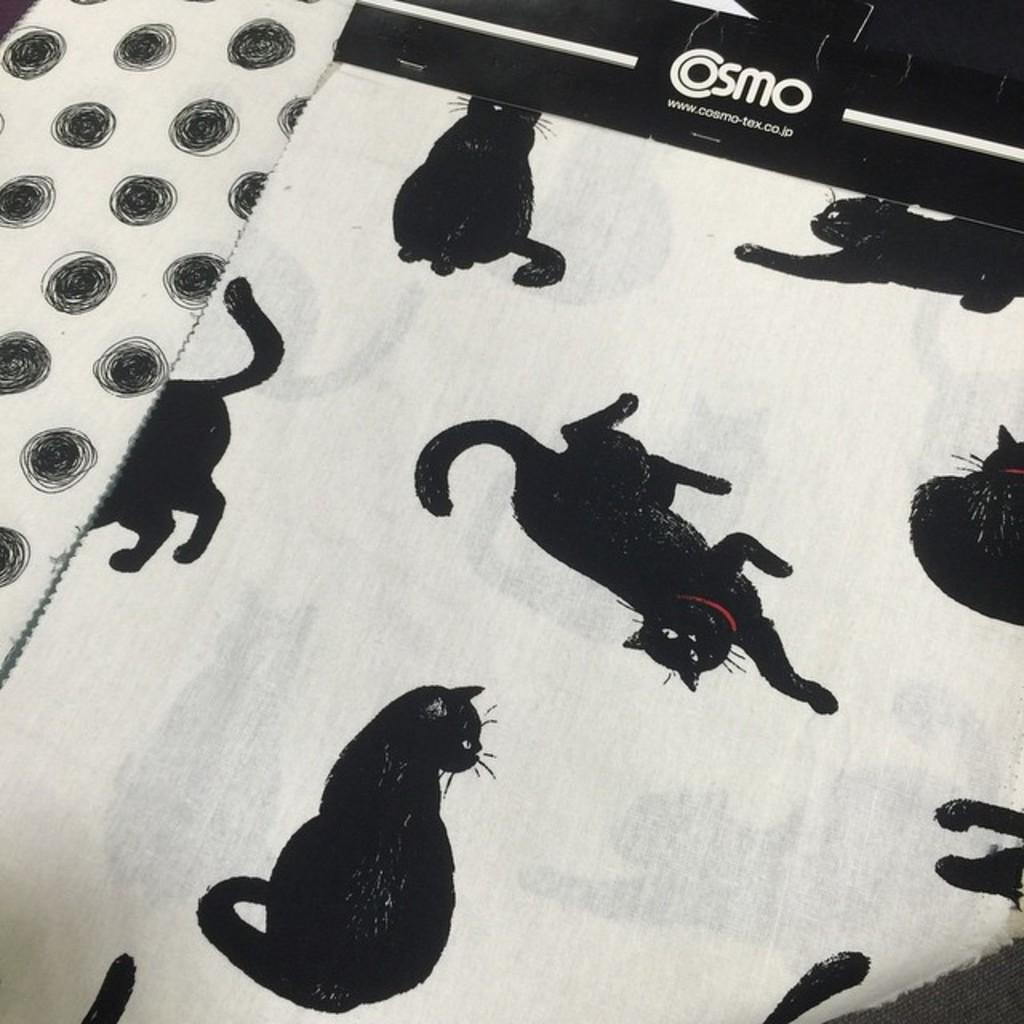What is present in the picture? There is a cloth in the picture. Can you describe the design on the cloth? The cloth has a cats design on it. What language is the kitty speaking in the image? There is no kitty present in the image, and cats do not speak any human language. 